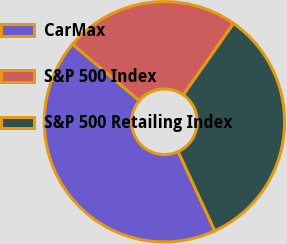Convert chart to OTSL. <chart><loc_0><loc_0><loc_500><loc_500><pie_chart><fcel>CarMax<fcel>S&P 500 Index<fcel>S&P 500 Retailing Index<nl><fcel>43.05%<fcel>23.6%<fcel>33.35%<nl></chart> 